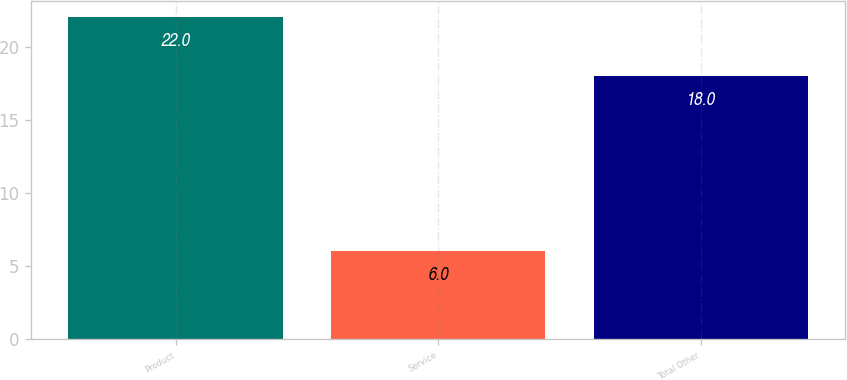Convert chart to OTSL. <chart><loc_0><loc_0><loc_500><loc_500><bar_chart><fcel>Product<fcel>Service<fcel>Total Other<nl><fcel>22<fcel>6<fcel>18<nl></chart> 